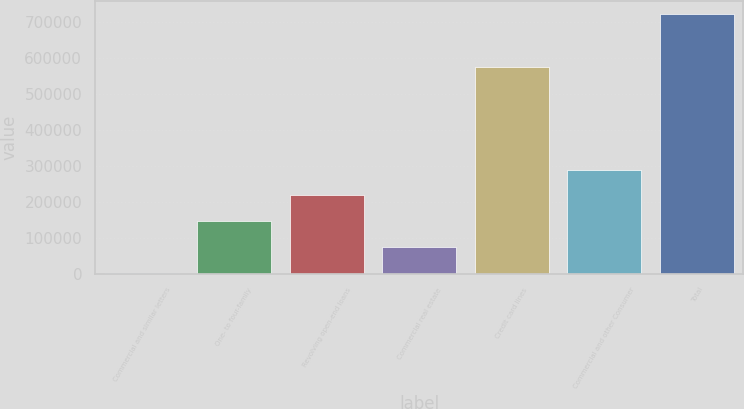Convert chart. <chart><loc_0><loc_0><loc_500><loc_500><bar_chart><fcel>Commercial and similar letters<fcel>One- to four-family<fcel>Revolving open-end loans<fcel>Commercial real estate<fcel>Credit card lines<fcel>Commercial and other Consumer<fcel>Total<nl><fcel>1544<fcel>145638<fcel>217684<fcel>73590.8<fcel>573945<fcel>289731<fcel>722012<nl></chart> 